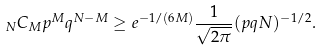Convert formula to latex. <formula><loc_0><loc_0><loc_500><loc_500>\, _ { N } C _ { M } p ^ { M } q ^ { N - M } \geq e ^ { - 1 / ( 6 M ) } \frac { 1 } { \sqrt { 2 \pi } } ( p q N ) ^ { - 1 / 2 } .</formula> 